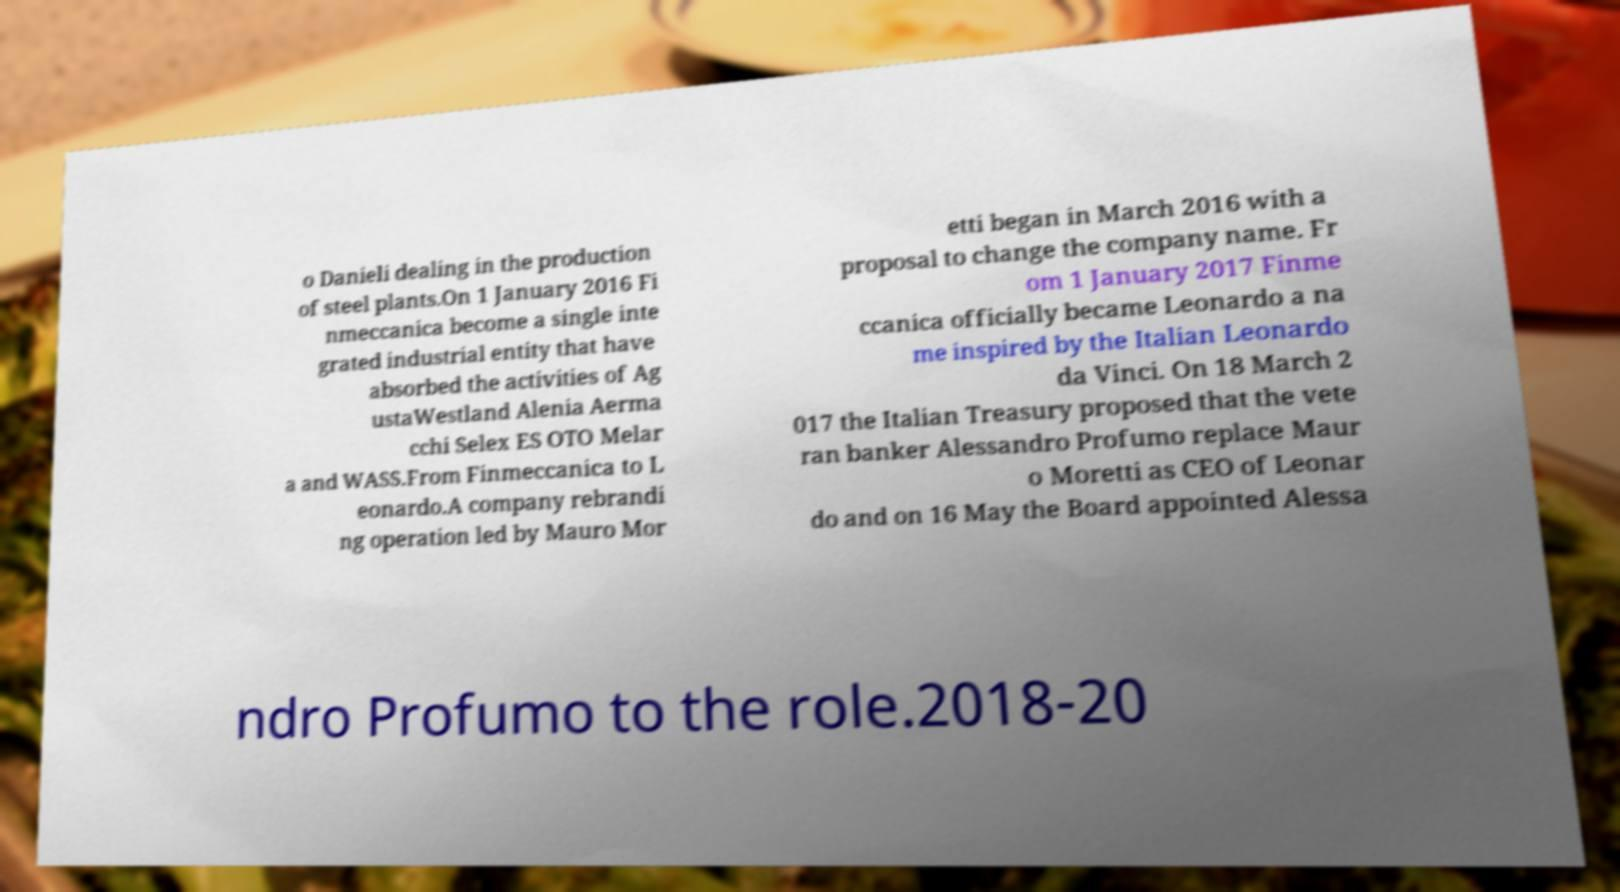Can you read and provide the text displayed in the image?This photo seems to have some interesting text. Can you extract and type it out for me? o Danieli dealing in the production of steel plants.On 1 January 2016 Fi nmeccanica become a single inte grated industrial entity that have absorbed the activities of Ag ustaWestland Alenia Aerma cchi Selex ES OTO Melar a and WASS.From Finmeccanica to L eonardo.A company rebrandi ng operation led by Mauro Mor etti began in March 2016 with a proposal to change the company name. Fr om 1 January 2017 Finme ccanica officially became Leonardo a na me inspired by the Italian Leonardo da Vinci. On 18 March 2 017 the Italian Treasury proposed that the vete ran banker Alessandro Profumo replace Maur o Moretti as CEO of Leonar do and on 16 May the Board appointed Alessa ndro Profumo to the role.2018-20 